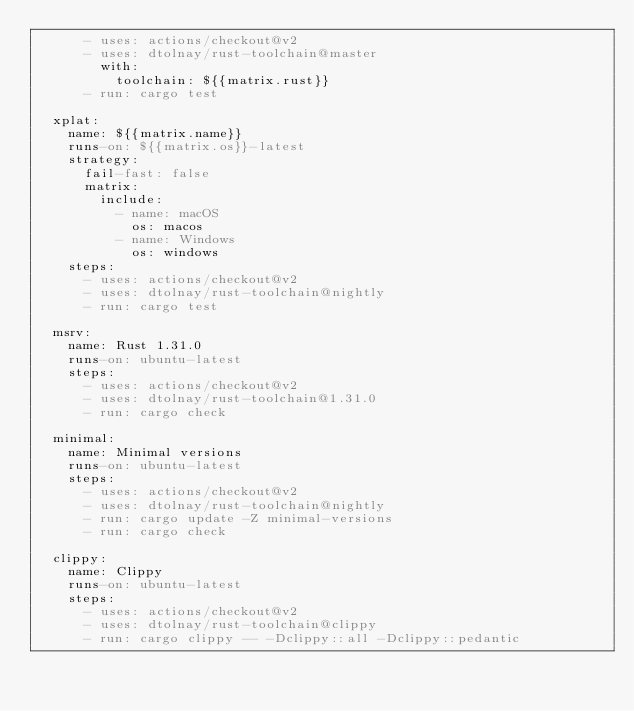<code> <loc_0><loc_0><loc_500><loc_500><_YAML_>      - uses: actions/checkout@v2
      - uses: dtolnay/rust-toolchain@master
        with:
          toolchain: ${{matrix.rust}}
      - run: cargo test

  xplat:
    name: ${{matrix.name}}
    runs-on: ${{matrix.os}}-latest
    strategy:
      fail-fast: false
      matrix:
        include:
          - name: macOS
            os: macos
          - name: Windows
            os: windows
    steps:
      - uses: actions/checkout@v2
      - uses: dtolnay/rust-toolchain@nightly
      - run: cargo test

  msrv:
    name: Rust 1.31.0
    runs-on: ubuntu-latest
    steps:
      - uses: actions/checkout@v2
      - uses: dtolnay/rust-toolchain@1.31.0
      - run: cargo check

  minimal:
    name: Minimal versions
    runs-on: ubuntu-latest
    steps:
      - uses: actions/checkout@v2
      - uses: dtolnay/rust-toolchain@nightly
      - run: cargo update -Z minimal-versions
      - run: cargo check

  clippy:
    name: Clippy
    runs-on: ubuntu-latest
    steps:
      - uses: actions/checkout@v2
      - uses: dtolnay/rust-toolchain@clippy
      - run: cargo clippy -- -Dclippy::all -Dclippy::pedantic
</code> 